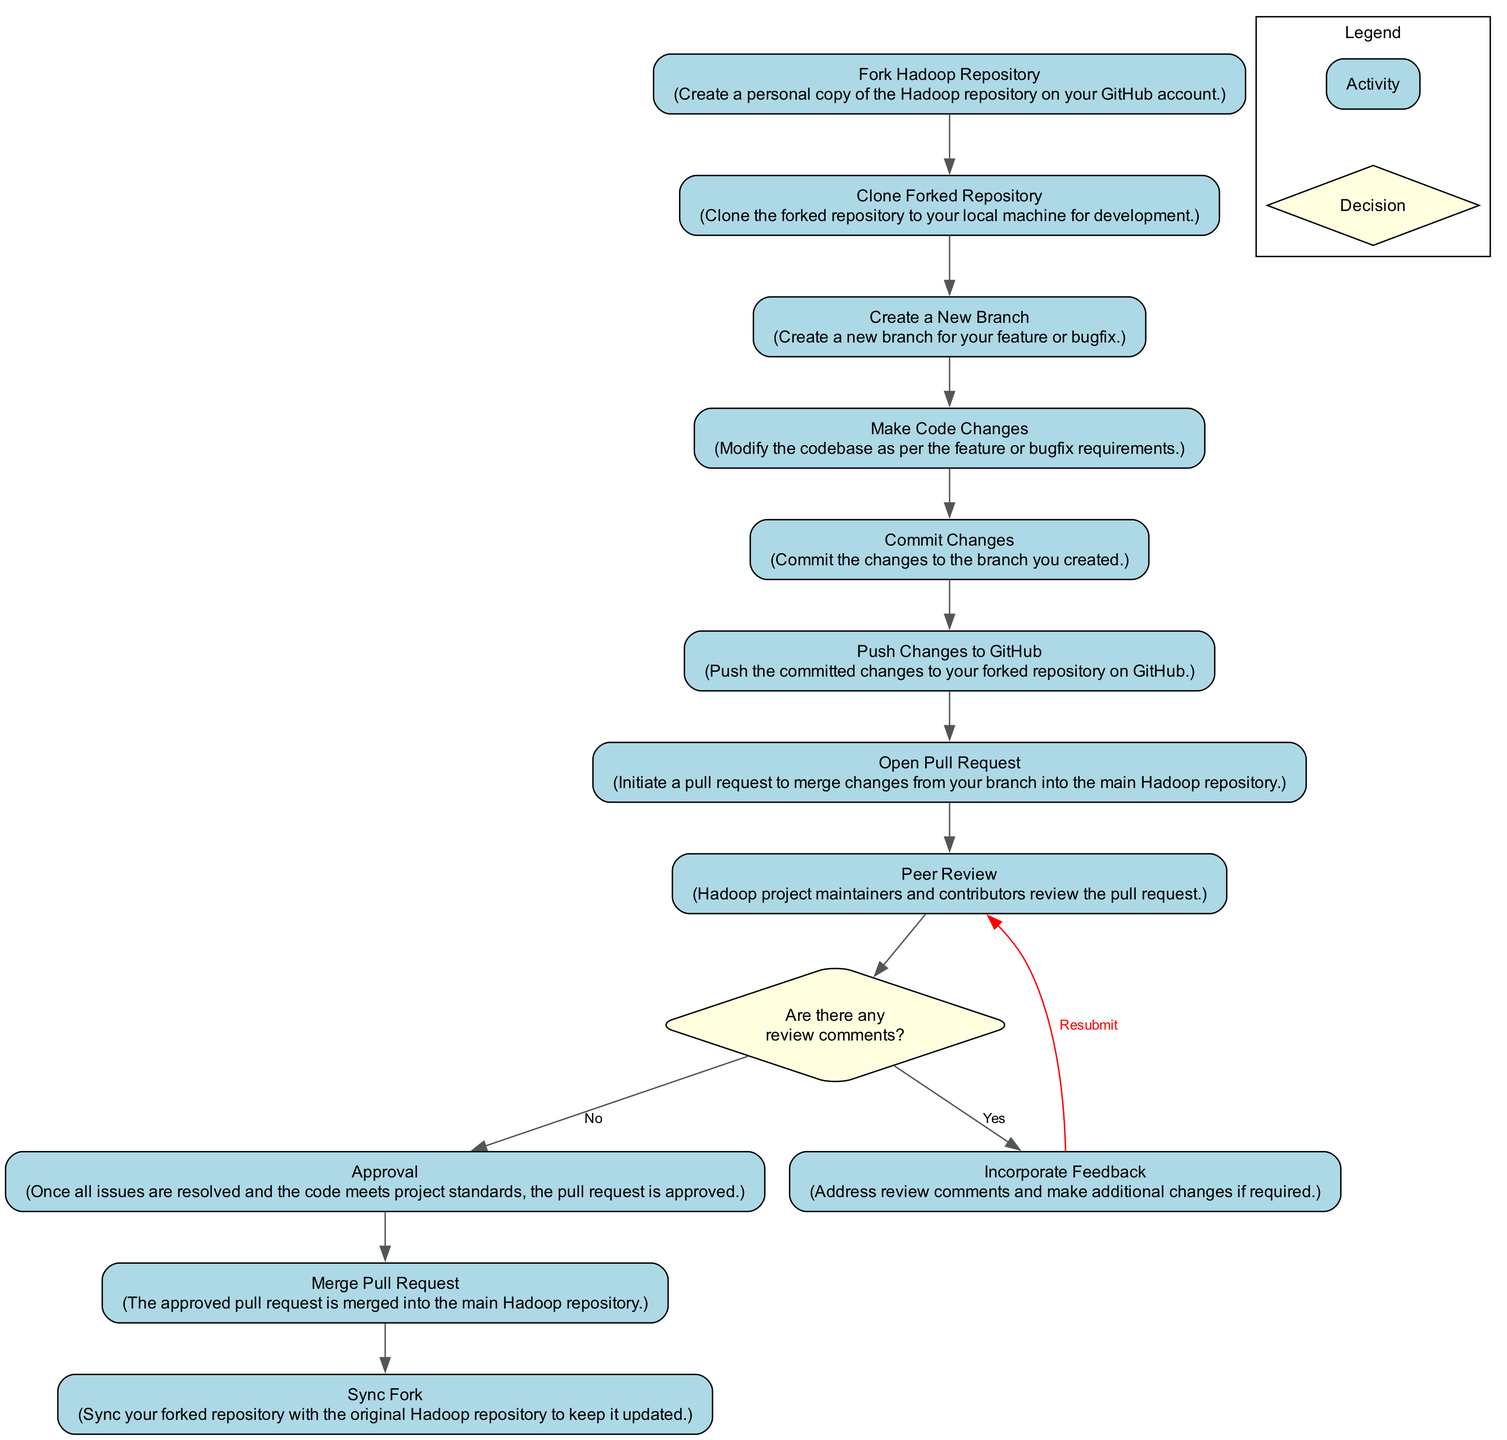What is the first activity in the diagram? The diagram starts with the "Fork Hadoop Repository" activity, which is identified as the first node in the sequence of activities.
Answer: Fork Hadoop Repository What is the final activity in the workflow? The final activity is "Merge Pull Request," which is the last node in the flow indicating the completion of the contribution process.
Answer: Merge Pull Request How many decision points are present in the diagram? There is a single decision point labeled "Are there any review comments?" represented as a diamond shape, which indicates a branching path based on the outcome of the peer review.
Answer: 1 What activity follows "Make Code Changes"? The activity that follows "Make Code Changes" is "Commit Changes," which is connected directly in the workflow sequence.
Answer: Commit Changes If there are review comments, what is the next activity? If there are review comments, the next activity is "Incorporate Feedback," indicating that the contributor must address any comments before moving forward.
Answer: Incorporate Feedback What happens after "Peer Review" in the diagram if there are no review comments? After "Peer Review," if there are no review comments, the workflow moves to the "Approval" activity, which indicates that the code has met the necessary review standards.
Answer: Approval Which activity comes before "Sync Fork"? The activity that comes just before "Sync Fork" is "Merge Pull Request," indicating that syncing of the forked repository happens after the changes have been merged.
Answer: Merge Pull Request Can you identify the process of incorporating feedback based on the diagram? The process involves addressing comments after the "Peer Review" in the "Incorporate Feedback" activity, which may loop back to the review if further adjustments are needed.
Answer: Incorporate Feedback What is the action taken in the "Open Pull Request" activity? In the "Open Pull Request" activity, the contributor initiates a pull request to merge their changes into the main Hadoop repository, signaling their readiness for review.
Answer: Initiate a pull request 